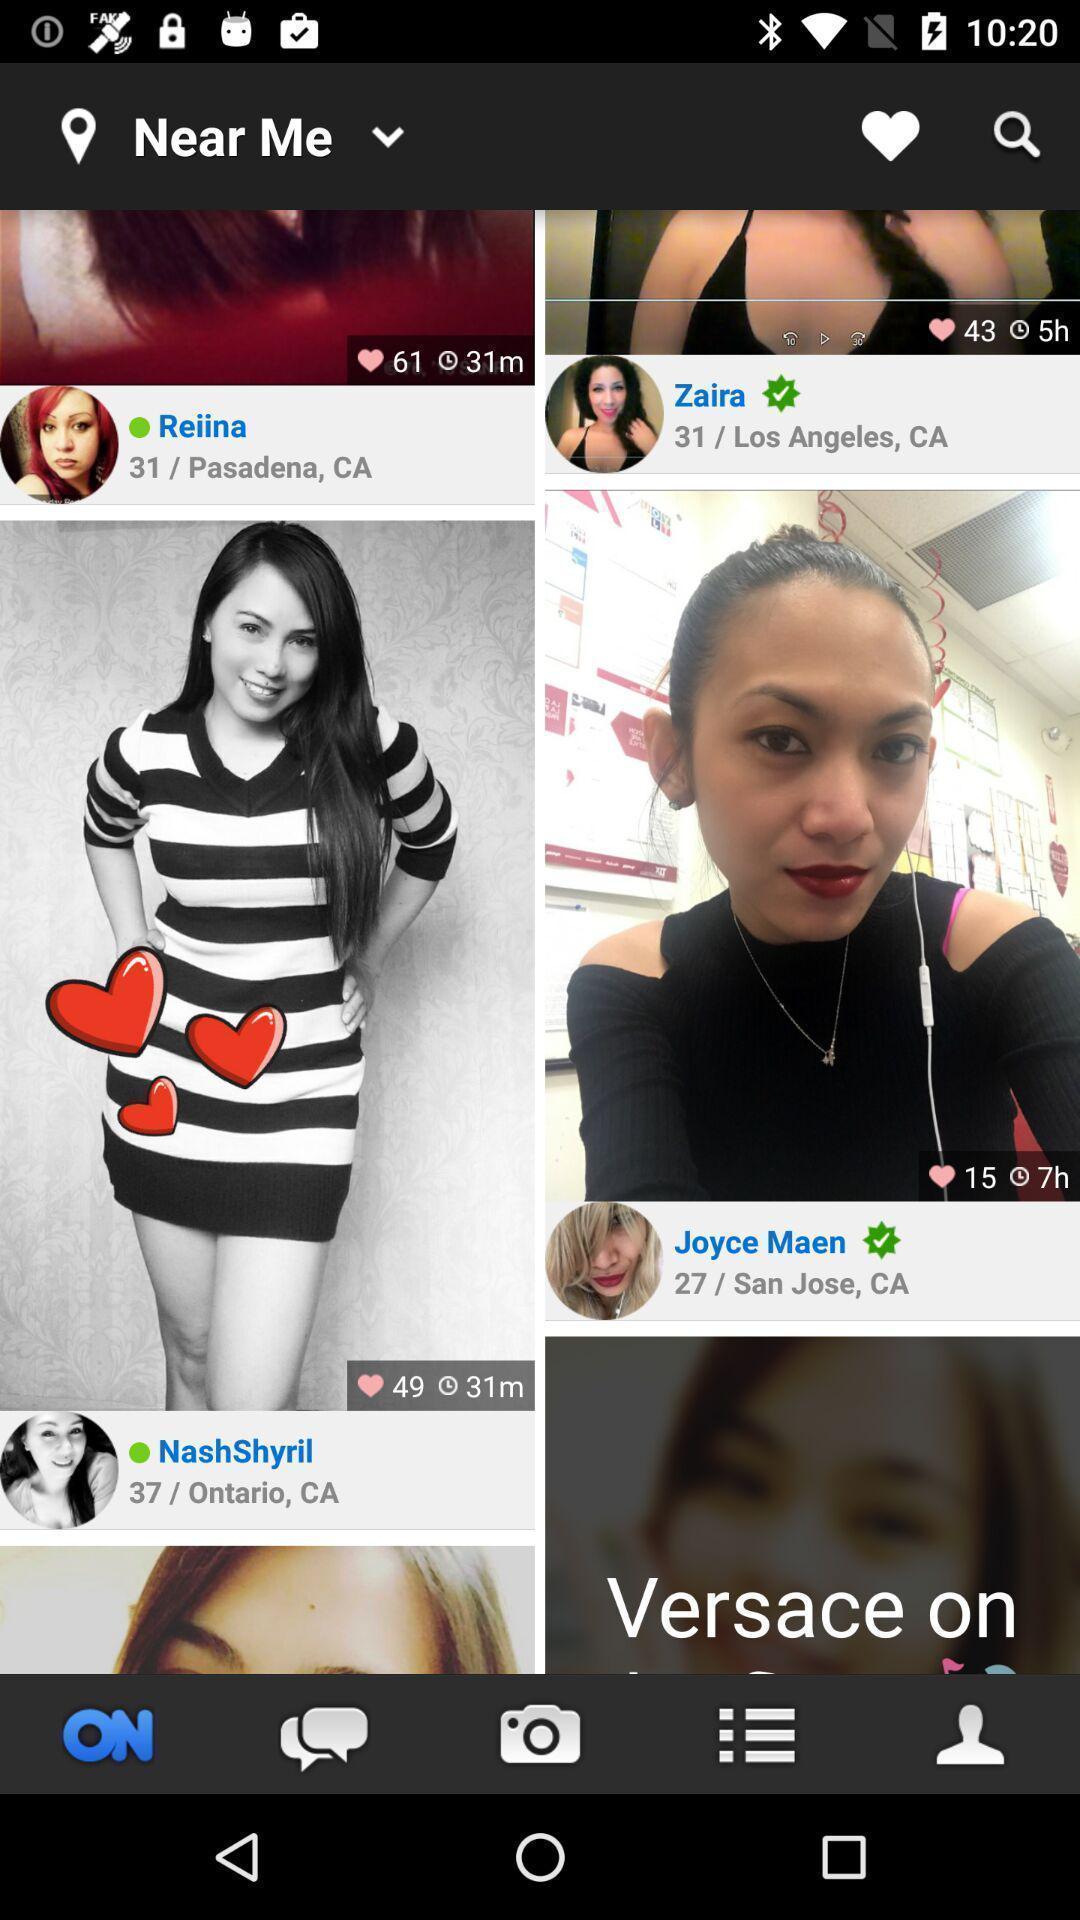Describe the visual elements of this screenshot. Screen displaying multiple users profile information. 